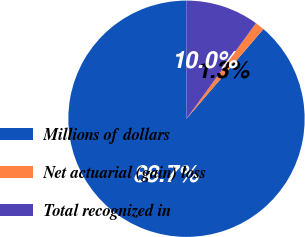Convert chart to OTSL. <chart><loc_0><loc_0><loc_500><loc_500><pie_chart><fcel>Millions of dollars<fcel>Net actuarial (gain) loss<fcel>Total recognized in<nl><fcel>88.69%<fcel>1.28%<fcel>10.02%<nl></chart> 